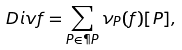<formula> <loc_0><loc_0><loc_500><loc_500>\ D i v f = \sum _ { P \in \P P } \nu _ { P } ( f ) [ P ] ,</formula> 